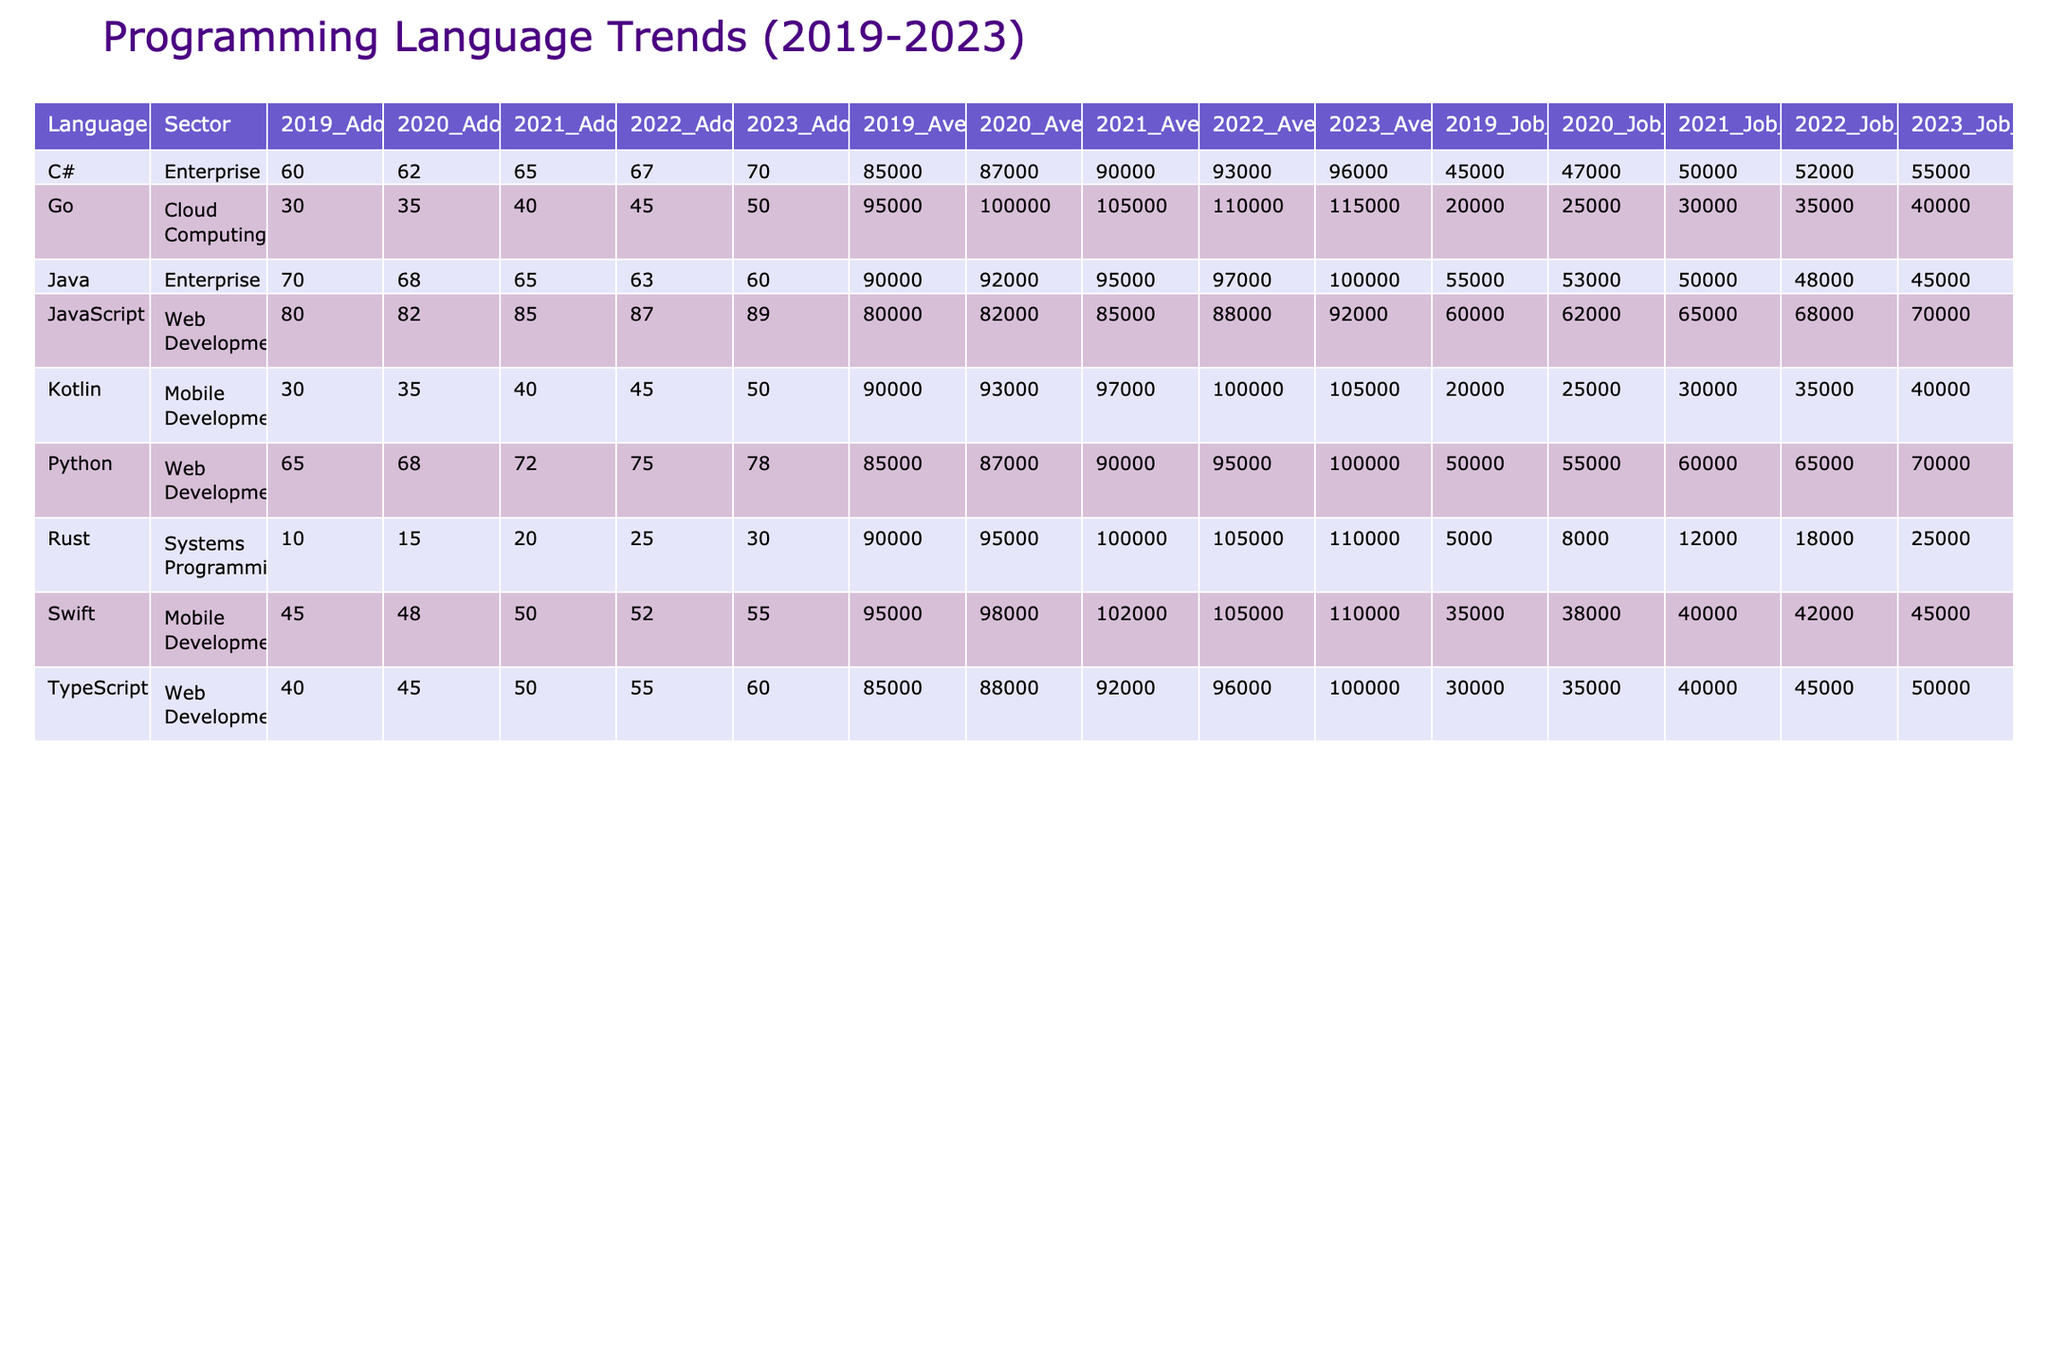What was the adoption rate of Python in 2023 for Web Development? The table shows that the adoption rate of Python for Web Development in 2023 is listed under the column "2023" for the "Python" and "Web Development" row, which reveals a value of 78.
Answer: 78 Which programming language had the highest average salary in 2023? By examining the "Average_Salary_2023" column and identifying the highest value across all programming languages, we find that Java had an average salary of 100,000.
Answer: 100000 How many job openings were there for Java in 2021? Looking at the "Job_Openings_2021" column for Java, it shows 50,000 job openings for that year.
Answer: 50000 What is the average adoption rate for TypeScript from 2019 to 2023? We sum the adoption rates for TypeScript across all years: (40 + 45 + 50 + 55 + 60) = 250. Dividing by the number of years (5), we get an average of 250/5 = 50.
Answer: 50 Did the adoption rate of Go increase every year from 2019 to 2023? Checking the adoption rates for Go per year: 30 (2019), 35 (2020), 40 (2021), 45 (2022), and 50 (2023), we see each value is greater than the previous, confirming a year-on-year increase.
Answer: Yes Which sector saw the highest average job openings for 2023? By reviewing the "Job_Openings_2023" column across sectors, we realize that Web Development had the most job openings at 70,000, while other sectors have lower counts.
Answer: 70000 What was the difference in average salaries between Python and Java in 2023? In 2023, Python's average salary is 100,000, and Java's is also 100,000. The difference is 100,000 - 100,000 = 0, resulting in no difference.
Answer: 0 Which language experienced the largest growth in adoption rate from 2019 to 2023? We calculate the growth for each language by subtracting the adoption rate in 2019 from that of 2023. Python: 78 - 65 = 13, JavaScript: 89 - 80 = 9, Java: 60 - 70 = -10, C#: 70 - 60 = 10, Go: 50 - 30 = 20, Rust: 30 - 10 = 20, TypeScript: 60 - 40 = 20, Swift: 55 - 45 = 10, Kotlin: 50 - 30 = 20. The largest growth is 20 for Go, Rust, TypeScript, and Kotlin.
Answer: Go, Rust, TypeScript, Kotlin What is the average adoption rate of C# over the past 5 years? The adoption rates for C# are: 60, 62, 65, 67, 70. Summing these gives 60 + 62 + 65 + 67 + 70 = 324. Dividing by 5 (the number of years), the average adoption rate is 324/5 = 64.8.
Answer: 64.8 